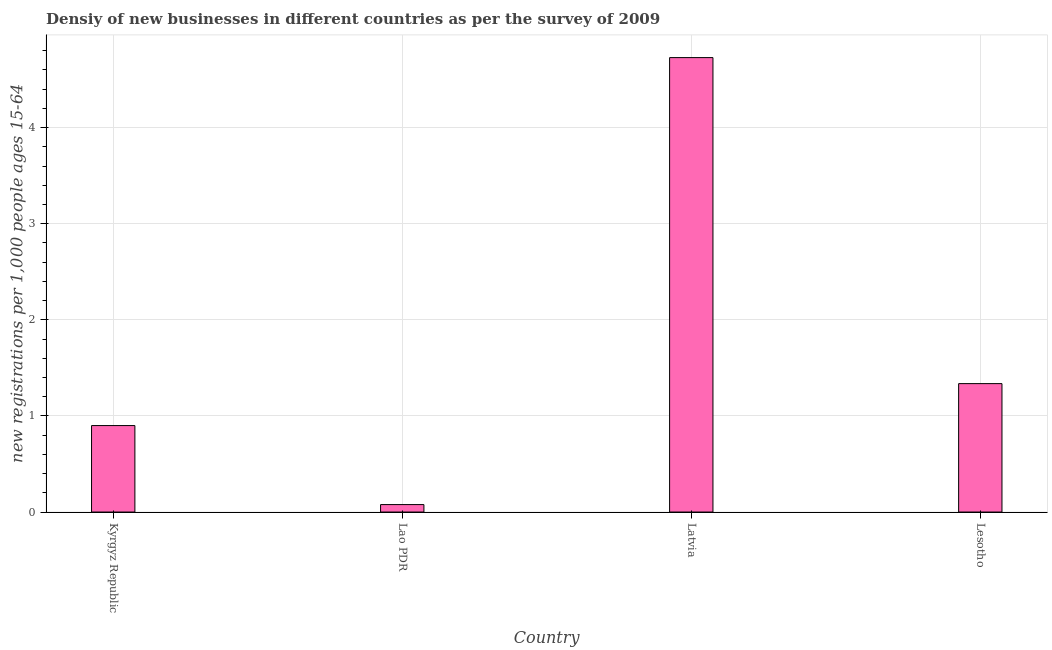Does the graph contain any zero values?
Offer a very short reply. No. Does the graph contain grids?
Offer a terse response. Yes. What is the title of the graph?
Provide a short and direct response. Densiy of new businesses in different countries as per the survey of 2009. What is the label or title of the X-axis?
Give a very brief answer. Country. What is the label or title of the Y-axis?
Provide a short and direct response. New registrations per 1,0 people ages 15-64. What is the density of new business in Lesotho?
Ensure brevity in your answer.  1.34. Across all countries, what is the maximum density of new business?
Provide a short and direct response. 4.73. Across all countries, what is the minimum density of new business?
Your answer should be very brief. 0.08. In which country was the density of new business maximum?
Ensure brevity in your answer.  Latvia. In which country was the density of new business minimum?
Ensure brevity in your answer.  Lao PDR. What is the sum of the density of new business?
Give a very brief answer. 7.04. What is the difference between the density of new business in Lao PDR and Lesotho?
Your answer should be compact. -1.26. What is the average density of new business per country?
Your answer should be compact. 1.76. What is the median density of new business?
Ensure brevity in your answer.  1.12. What is the ratio of the density of new business in Kyrgyz Republic to that in Lesotho?
Offer a terse response. 0.67. Is the density of new business in Latvia less than that in Lesotho?
Offer a very short reply. No. Is the difference between the density of new business in Lao PDR and Lesotho greater than the difference between any two countries?
Make the answer very short. No. What is the difference between the highest and the second highest density of new business?
Provide a succinct answer. 3.39. What is the difference between the highest and the lowest density of new business?
Keep it short and to the point. 4.65. In how many countries, is the density of new business greater than the average density of new business taken over all countries?
Ensure brevity in your answer.  1. How many bars are there?
Give a very brief answer. 4. How many countries are there in the graph?
Offer a terse response. 4. What is the difference between two consecutive major ticks on the Y-axis?
Keep it short and to the point. 1. Are the values on the major ticks of Y-axis written in scientific E-notation?
Make the answer very short. No. What is the new registrations per 1,000 people ages 15-64 in Kyrgyz Republic?
Offer a terse response. 0.9. What is the new registrations per 1,000 people ages 15-64 in Lao PDR?
Your response must be concise. 0.08. What is the new registrations per 1,000 people ages 15-64 in Latvia?
Your response must be concise. 4.73. What is the new registrations per 1,000 people ages 15-64 of Lesotho?
Keep it short and to the point. 1.34. What is the difference between the new registrations per 1,000 people ages 15-64 in Kyrgyz Republic and Lao PDR?
Your answer should be compact. 0.82. What is the difference between the new registrations per 1,000 people ages 15-64 in Kyrgyz Republic and Latvia?
Provide a succinct answer. -3.83. What is the difference between the new registrations per 1,000 people ages 15-64 in Kyrgyz Republic and Lesotho?
Keep it short and to the point. -0.44. What is the difference between the new registrations per 1,000 people ages 15-64 in Lao PDR and Latvia?
Offer a very short reply. -4.65. What is the difference between the new registrations per 1,000 people ages 15-64 in Lao PDR and Lesotho?
Offer a terse response. -1.26. What is the difference between the new registrations per 1,000 people ages 15-64 in Latvia and Lesotho?
Keep it short and to the point. 3.39. What is the ratio of the new registrations per 1,000 people ages 15-64 in Kyrgyz Republic to that in Lao PDR?
Your answer should be very brief. 11.6. What is the ratio of the new registrations per 1,000 people ages 15-64 in Kyrgyz Republic to that in Latvia?
Ensure brevity in your answer.  0.19. What is the ratio of the new registrations per 1,000 people ages 15-64 in Kyrgyz Republic to that in Lesotho?
Make the answer very short. 0.67. What is the ratio of the new registrations per 1,000 people ages 15-64 in Lao PDR to that in Latvia?
Make the answer very short. 0.02. What is the ratio of the new registrations per 1,000 people ages 15-64 in Lao PDR to that in Lesotho?
Ensure brevity in your answer.  0.06. What is the ratio of the new registrations per 1,000 people ages 15-64 in Latvia to that in Lesotho?
Provide a succinct answer. 3.54. 